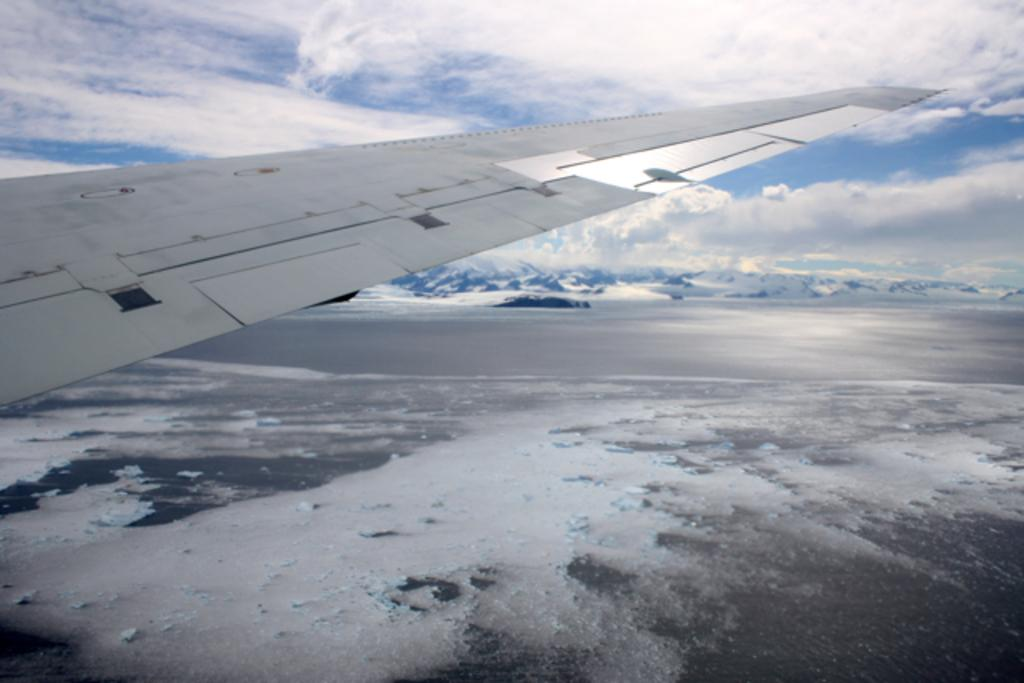What is the main subject of the image? The main subject of the image is a wing of an airplane. What can be seen in the background of the image? There are clouds and the sky visible in the background of the image. How many boys are holding fruit in the image? There are no boys or fruit present in the image; it features a wing of an airplane and clouds in the sky. 